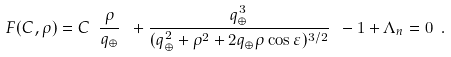Convert formula to latex. <formula><loc_0><loc_0><loc_500><loc_500>F ( C , \rho ) = C \ \frac { \rho } { q _ { \oplus } } \ + \frac { q _ { \oplus } ^ { 3 } } { ( q _ { \oplus } ^ { 2 } + \rho ^ { 2 } + 2 q _ { \oplus } \rho \cos \varepsilon ) ^ { 3 / 2 } } \ - 1 + \Lambda _ { n } = 0 \ .</formula> 